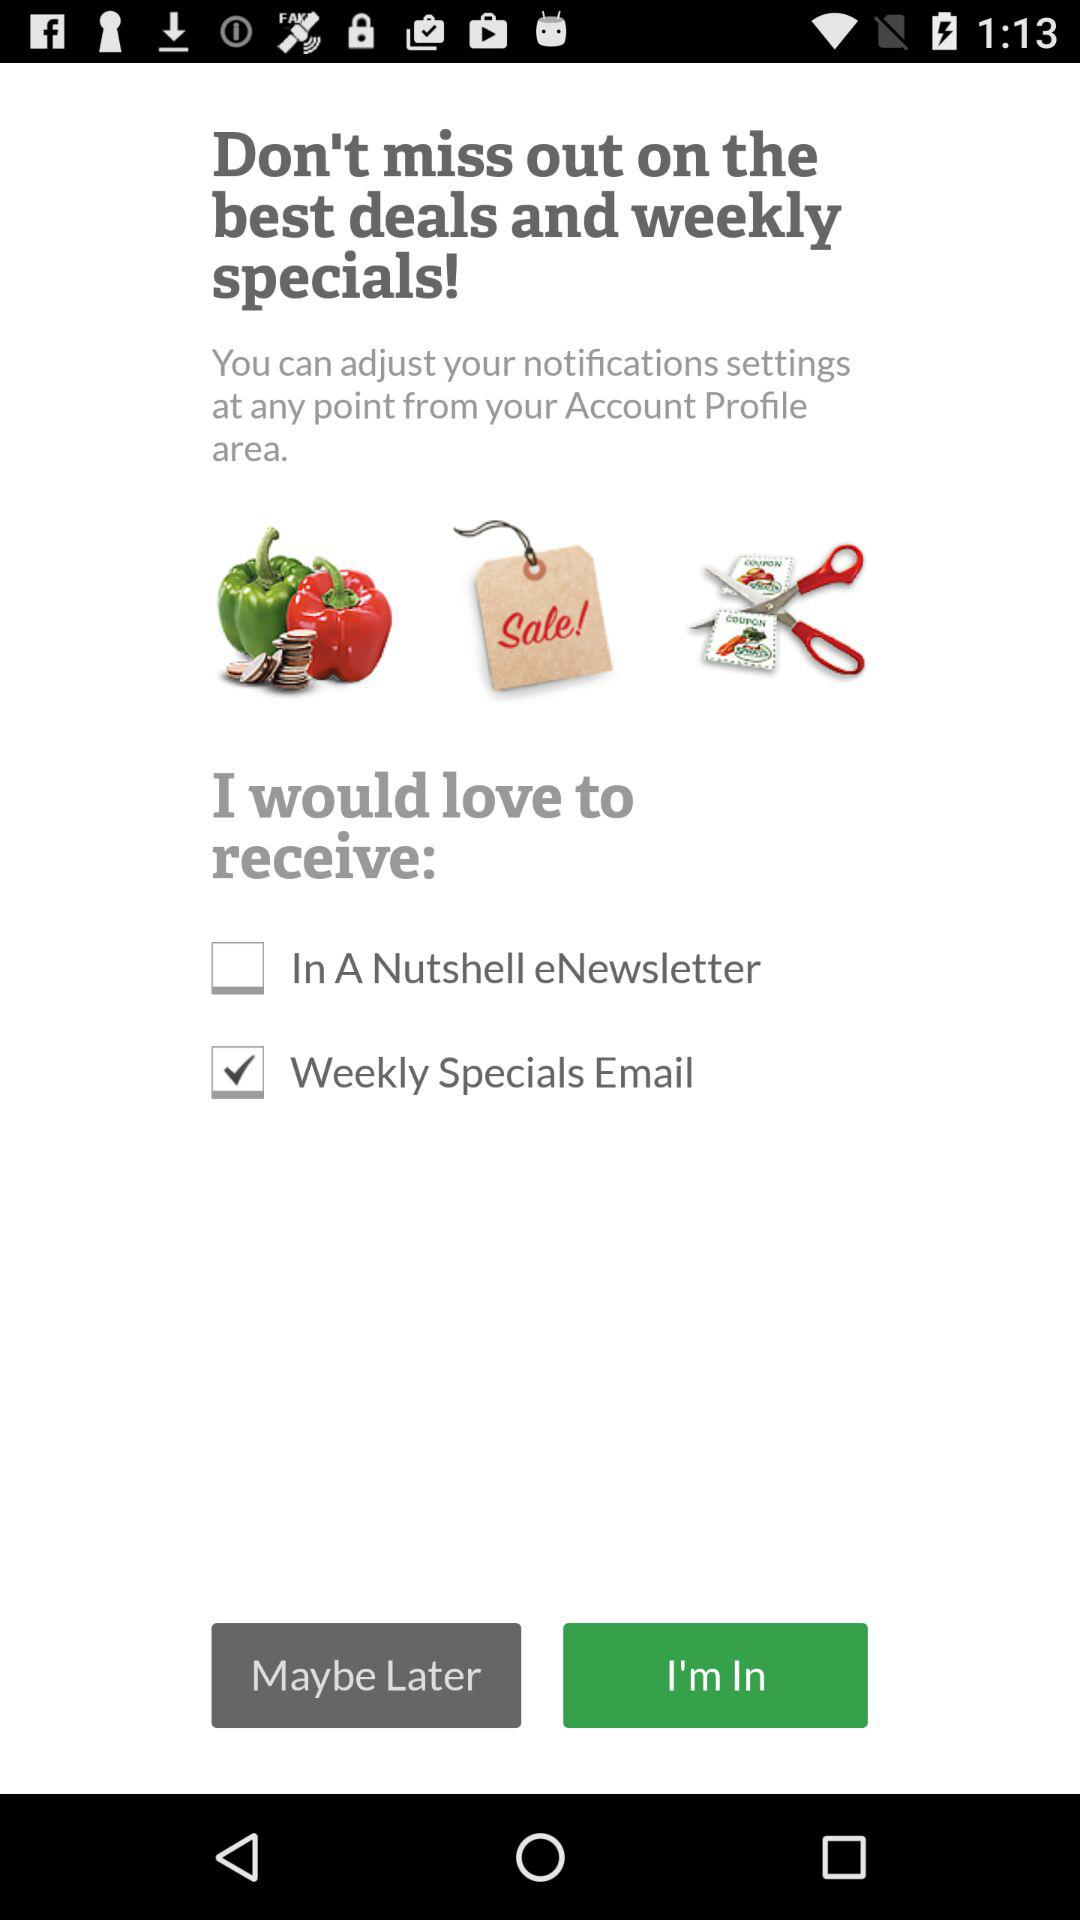What is the status of the "In A Nutshell eNewsletter"? The status is off. 